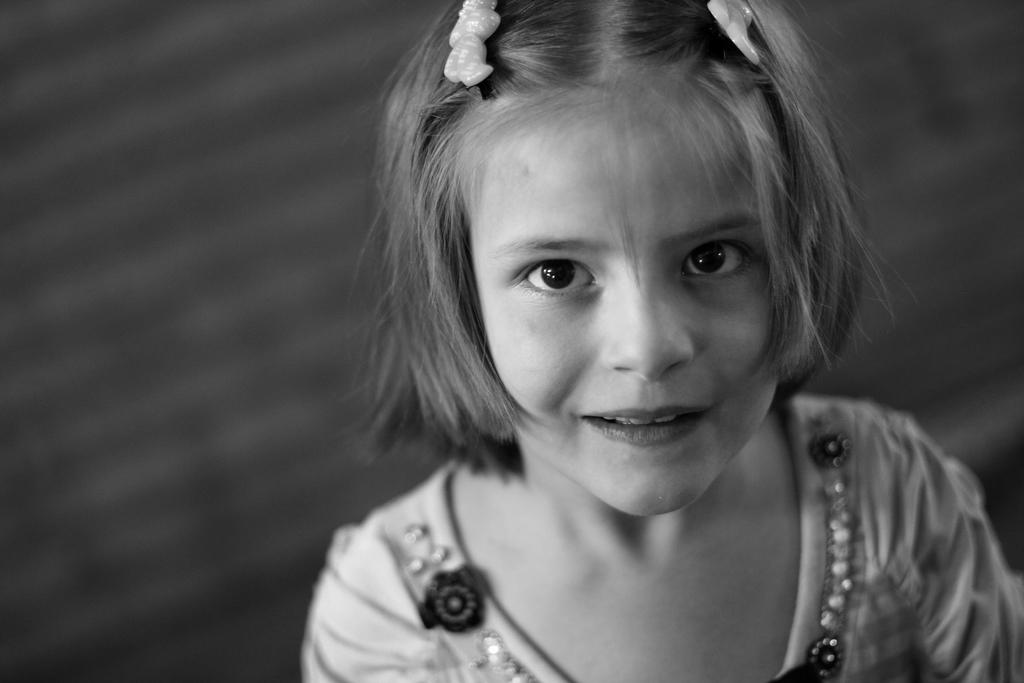What is the color scheme of the image? The image is black and white. Who is present in the image? There is a kid in the image. What is the kid wearing? The kid is wearing clothes. Can you describe the background of the image? The background of the image is blurred. What type of drug can be seen in the image? There is no drug present in the image. Is there a scale visible in the image? There is no scale present in the image. 